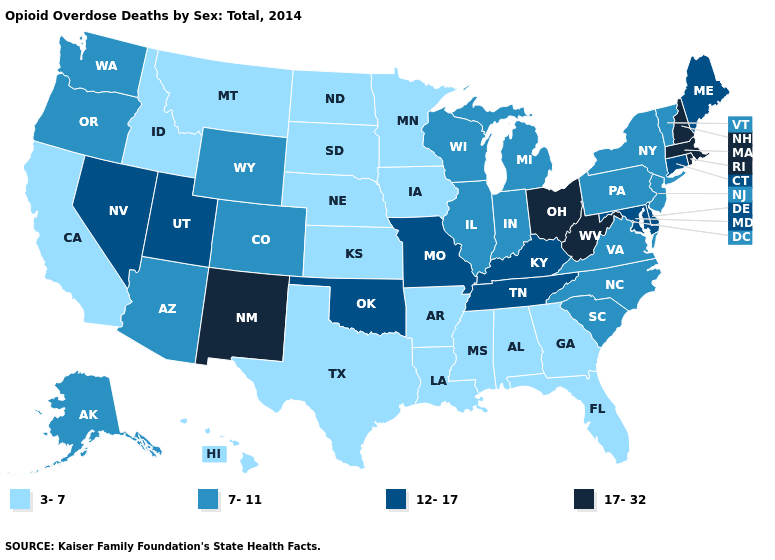Name the states that have a value in the range 17-32?
Quick response, please. Massachusetts, New Hampshire, New Mexico, Ohio, Rhode Island, West Virginia. Which states have the lowest value in the West?
Write a very short answer. California, Hawaii, Idaho, Montana. What is the value of Mississippi?
Concise answer only. 3-7. What is the lowest value in states that border Wisconsin?
Answer briefly. 3-7. What is the highest value in the South ?
Quick response, please. 17-32. Among the states that border Oregon , which have the lowest value?
Concise answer only. California, Idaho. What is the highest value in states that border Delaware?
Be succinct. 12-17. Name the states that have a value in the range 7-11?
Give a very brief answer. Alaska, Arizona, Colorado, Illinois, Indiana, Michigan, New Jersey, New York, North Carolina, Oregon, Pennsylvania, South Carolina, Vermont, Virginia, Washington, Wisconsin, Wyoming. What is the value of Oklahoma?
Concise answer only. 12-17. Does the first symbol in the legend represent the smallest category?
Concise answer only. Yes. Among the states that border Maryland , which have the lowest value?
Be succinct. Pennsylvania, Virginia. Name the states that have a value in the range 7-11?
Concise answer only. Alaska, Arizona, Colorado, Illinois, Indiana, Michigan, New Jersey, New York, North Carolina, Oregon, Pennsylvania, South Carolina, Vermont, Virginia, Washington, Wisconsin, Wyoming. Among the states that border Indiana , does Illinois have the lowest value?
Be succinct. Yes. Among the states that border Connecticut , does Massachusetts have the highest value?
Concise answer only. Yes. Which states hav the highest value in the MidWest?
Concise answer only. Ohio. 